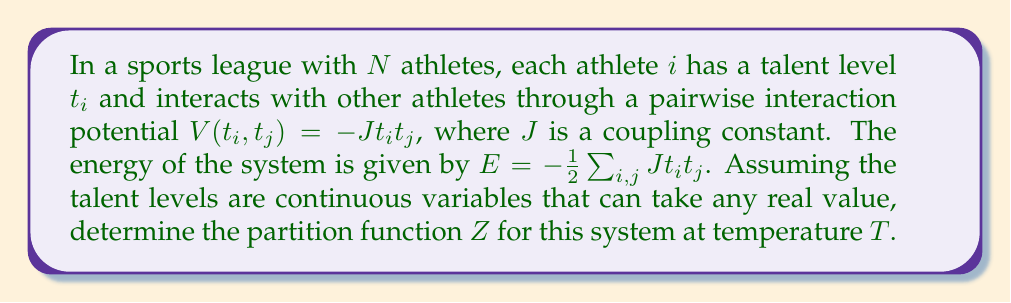Show me your answer to this math problem. To solve this problem, we'll follow these steps:

1) The partition function $Z$ is given by:
   $$Z = \int e^{-\beta E} dt_1 dt_2 ... dt_N$$
   where $\beta = \frac{1}{k_B T}$, $k_B$ is Boltzmann's constant, and $T$ is temperature.

2) Substituting the energy expression:
   $$Z = \int exp(\frac{\beta}{2} \sum_{i,j} J t_i t_j) dt_1 dt_2 ... dt_N$$

3) We can rewrite the sum in matrix form:
   $$Z = \int exp(\frac{\beta J}{2} \mathbf{t}^T \mathbf{A} \mathbf{t}) d\mathbf{t}$$
   where $\mathbf{t}$ is the vector of talent levels and $\mathbf{A}$ is a matrix with 1's everywhere except on the diagonal.

4) This integral is a multidimensional Gaussian integral. The general form of such an integral is:
   $$\int exp(-\frac{1}{2}\mathbf{x}^T \mathbf{M} \mathbf{x}) d\mathbf{x} = \sqrt{\frac{(2\pi)^N}{det(\mathbf{M})}}$$

5) In our case, $\mathbf{M} = -\beta J \mathbf{A}$. The determinant of $\mathbf{A}$ is $N-1$ for an $N \times N$ matrix.

6) Therefore, our partition function becomes:
   $$Z = \sqrt{\frac{(2\pi)^N}{det(-\beta J \mathbf{A})}} = \sqrt{\frac{(2\pi)^N}{(-\beta J)^N (N-1)}}$$

7) Simplifying:
   $$Z = \sqrt{\frac{(2\pi)^N}{(\beta J)^N (N-1)}} = \left(\frac{2\pi}{\beta J}\right)^{N/2} \frac{1}{\sqrt{N-1}}$$
Answer: $$Z = \left(\frac{2\pi}{\beta J}\right)^{N/2} \frac{1}{\sqrt{N-1}}$$ 